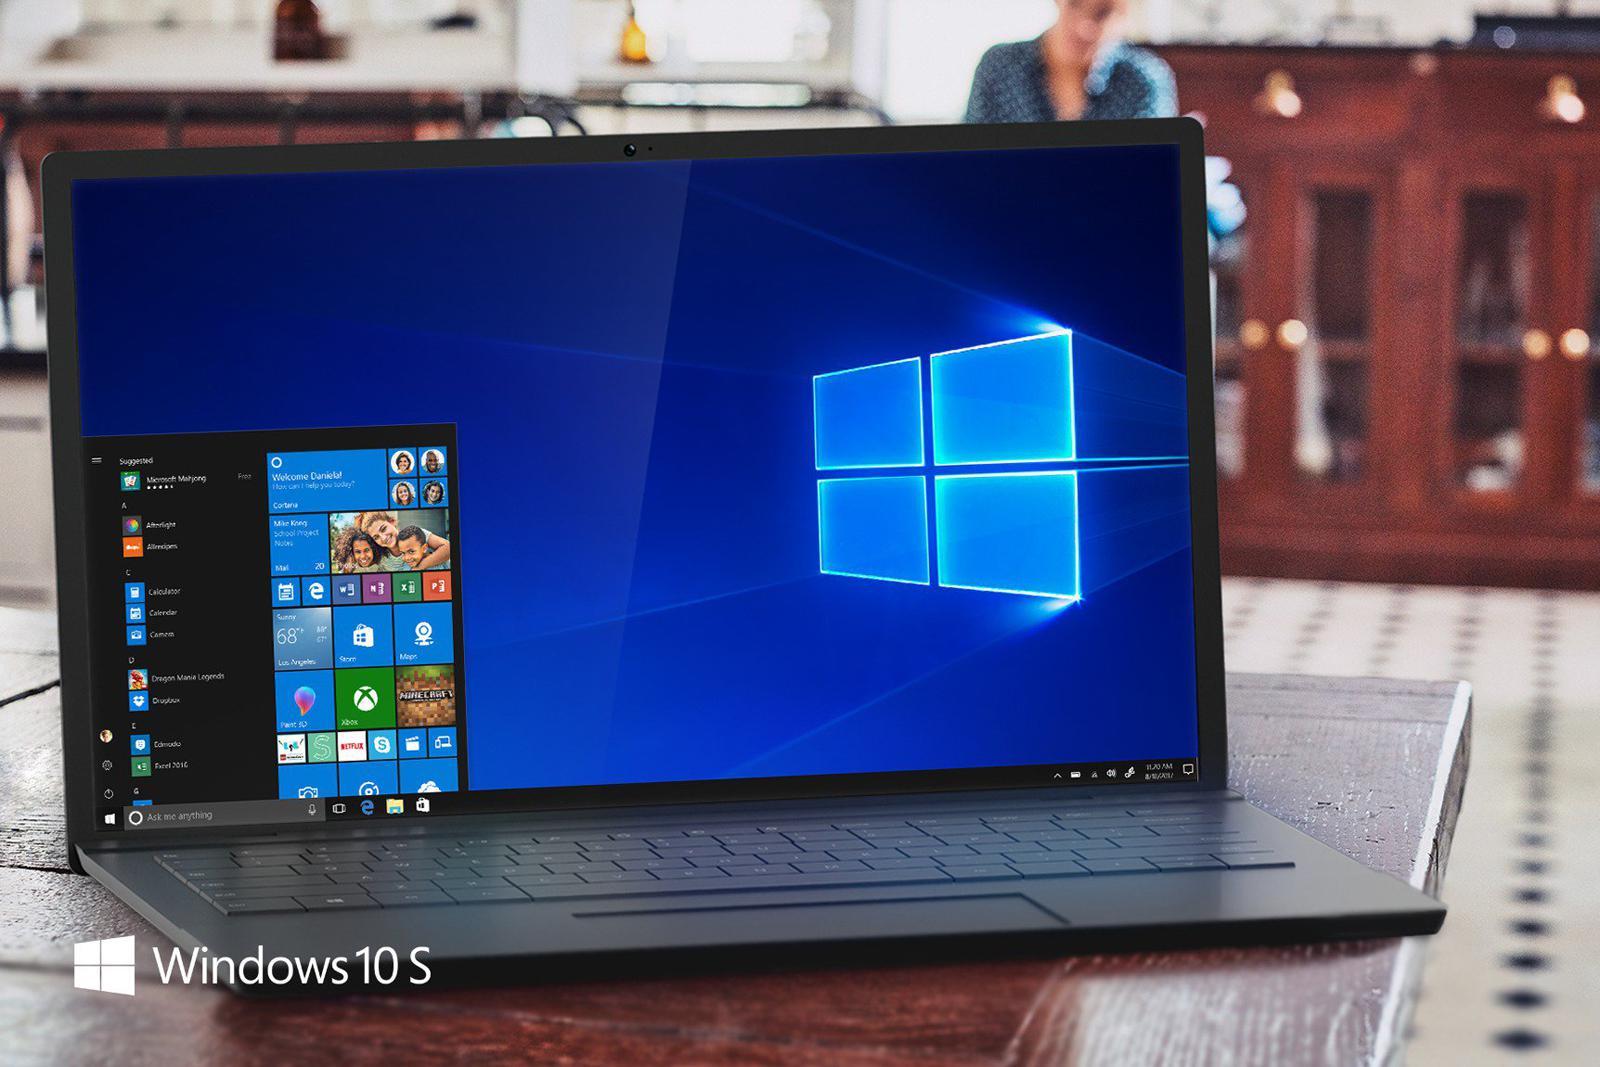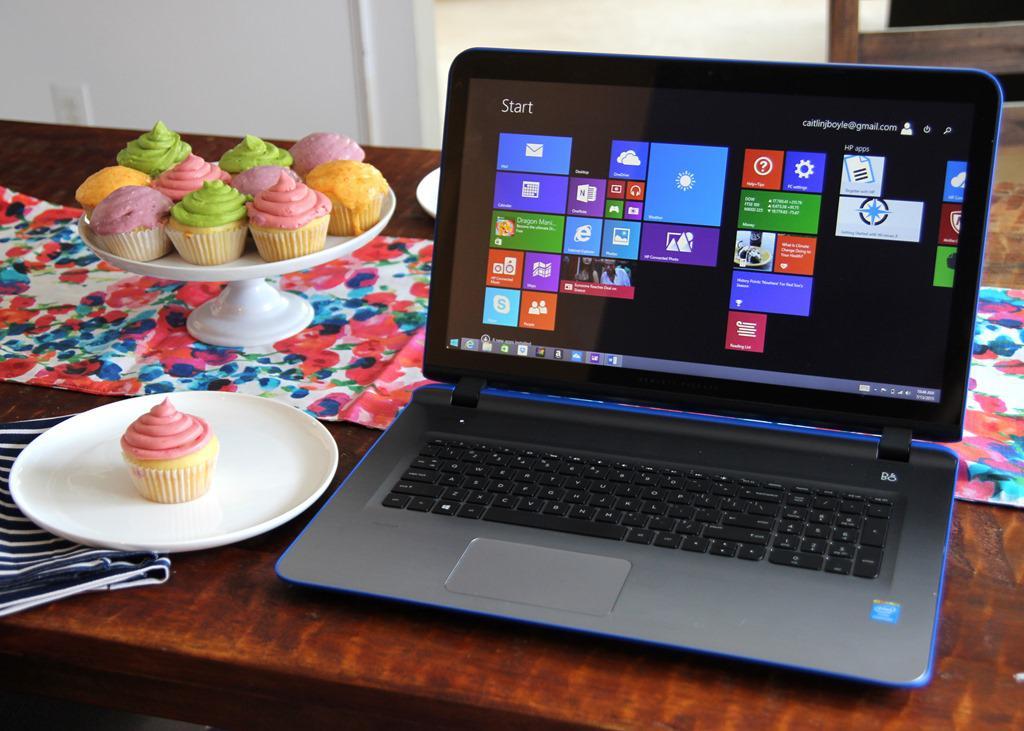The first image is the image on the left, the second image is the image on the right. Considering the images on both sides, is "One of the pictures has more than one laptop." valid? Answer yes or no. No. The first image is the image on the left, the second image is the image on the right. Evaluate the accuracy of this statement regarding the images: "There are more computers in the image on the left.". Is it true? Answer yes or no. No. 